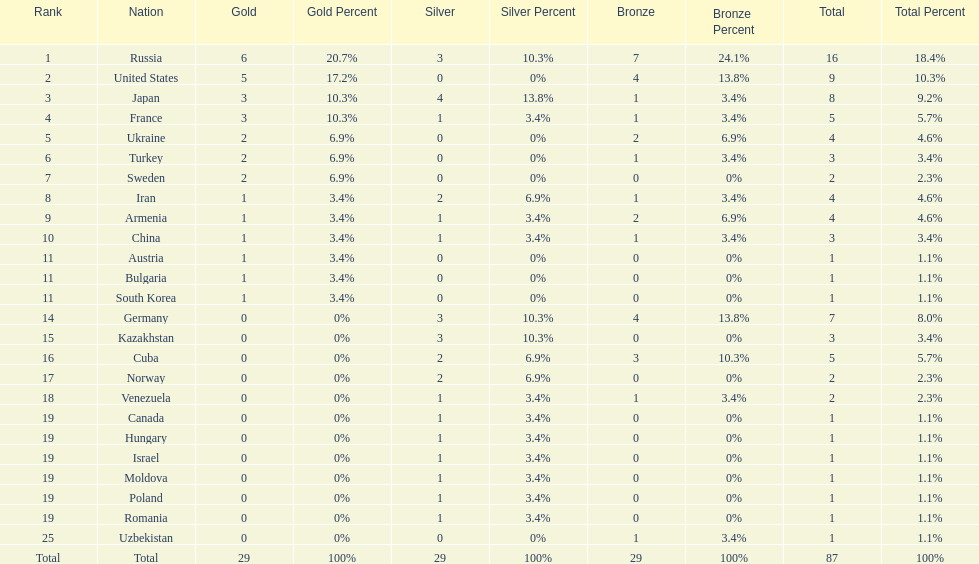Japan and france each won how many gold medals? 3. Give me the full table as a dictionary. {'header': ['Rank', 'Nation', 'Gold', 'Gold Percent', 'Silver', 'Silver Percent', 'Bronze', 'Bronze Percent', 'Total', 'Total Percent'], 'rows': [['1', 'Russia', '6', '20.7%', '3', '10.3%', '7', '24.1%', '16', '18.4%'], ['2', 'United States', '5', '17.2%', '0', '0%', '4', '13.8%', '9', '10.3%'], ['3', 'Japan', '3', '10.3%', '4', '13.8%', '1', '3.4%', '8', '9.2%'], ['4', 'France', '3', '10.3%', '1', '3.4%', '1', '3.4%', '5', '5.7%'], ['5', 'Ukraine', '2', '6.9%', '0', '0%', '2', '6.9%', '4', '4.6%'], ['6', 'Turkey', '2', '6.9%', '0', '0%', '1', '3.4%', '3', '3.4%'], ['7', 'Sweden', '2', '6.9%', '0', '0%', '0', '0%', '2', '2.3%'], ['8', 'Iran', '1', '3.4%', '2', '6.9%', '1', '3.4%', '4', '4.6%'], ['9', 'Armenia', '1', '3.4%', '1', '3.4%', '2', '6.9%', '4', '4.6%'], ['10', 'China', '1', '3.4%', '1', '3.4%', '1', '3.4%', '3', '3.4%'], ['11', 'Austria', '1', '3.4%', '0', '0%', '0', '0%', '1', '1.1%'], ['11', 'Bulgaria', '1', '3.4%', '0', '0%', '0', '0%', '1', '1.1%'], ['11', 'South Korea', '1', '3.4%', '0', '0%', '0', '0%', '1', '1.1%'], ['14', 'Germany', '0', '0%', '3', '10.3%', '4', '13.8%', '7', '8.0%'], ['15', 'Kazakhstan', '0', '0%', '3', '10.3%', '0', '0%', '3', '3.4%'], ['16', 'Cuba', '0', '0%', '2', '6.9%', '3', '10.3%', '5', '5.7%'], ['17', 'Norway', '0', '0%', '2', '6.9%', '0', '0%', '2', '2.3%'], ['18', 'Venezuela', '0', '0%', '1', '3.4%', '1', '3.4%', '2', '2.3%'], ['19', 'Canada', '0', '0%', '1', '3.4%', '0', '0%', '1', '1.1%'], ['19', 'Hungary', '0', '0%', '1', '3.4%', '0', '0%', '1', '1.1%'], ['19', 'Israel', '0', '0%', '1', '3.4%', '0', '0%', '1', '1.1%'], ['19', 'Moldova', '0', '0%', '1', '3.4%', '0', '0%', '1', '1.1%'], ['19', 'Poland', '0', '0%', '1', '3.4%', '0', '0%', '1', '1.1%'], ['19', 'Romania', '0', '0%', '1', '3.4%', '0', '0%', '1', '1.1%'], ['25', 'Uzbekistan', '0', '0%', '0', '0%', '1', '3.4%', '1', '1.1%'], ['Total', 'Total', '29', '100%', '29', '100%', '29', '100%', '87', '100%']]} 